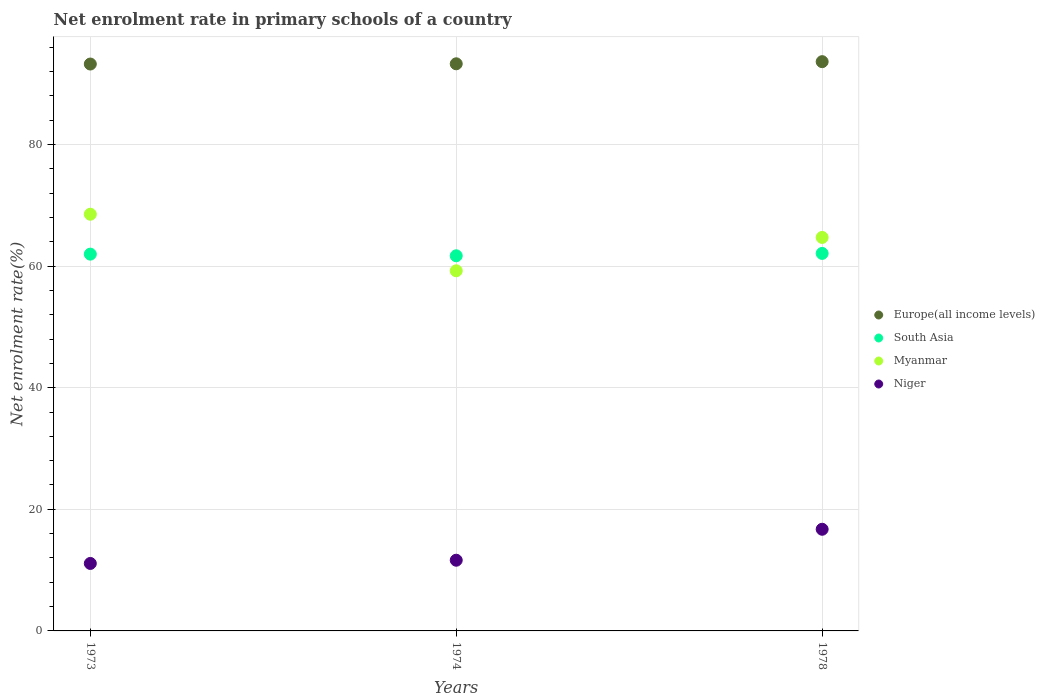How many different coloured dotlines are there?
Provide a succinct answer. 4. What is the net enrolment rate in primary schools in Myanmar in 1974?
Ensure brevity in your answer.  59.22. Across all years, what is the maximum net enrolment rate in primary schools in Europe(all income levels)?
Offer a terse response. 93.61. Across all years, what is the minimum net enrolment rate in primary schools in Myanmar?
Provide a short and direct response. 59.22. In which year was the net enrolment rate in primary schools in Europe(all income levels) maximum?
Provide a short and direct response. 1978. In which year was the net enrolment rate in primary schools in Europe(all income levels) minimum?
Provide a succinct answer. 1973. What is the total net enrolment rate in primary schools in South Asia in the graph?
Offer a very short reply. 185.73. What is the difference between the net enrolment rate in primary schools in Europe(all income levels) in 1973 and that in 1974?
Make the answer very short. -0.04. What is the difference between the net enrolment rate in primary schools in South Asia in 1973 and the net enrolment rate in primary schools in Niger in 1978?
Offer a terse response. 45.24. What is the average net enrolment rate in primary schools in South Asia per year?
Provide a succinct answer. 61.91. In the year 1973, what is the difference between the net enrolment rate in primary schools in Myanmar and net enrolment rate in primary schools in Niger?
Give a very brief answer. 57.43. In how many years, is the net enrolment rate in primary schools in Niger greater than 24 %?
Offer a very short reply. 0. What is the ratio of the net enrolment rate in primary schools in Europe(all income levels) in 1974 to that in 1978?
Make the answer very short. 1. Is the net enrolment rate in primary schools in Niger in 1973 less than that in 1974?
Provide a short and direct response. Yes. Is the difference between the net enrolment rate in primary schools in Myanmar in 1973 and 1974 greater than the difference between the net enrolment rate in primary schools in Niger in 1973 and 1974?
Provide a short and direct response. Yes. What is the difference between the highest and the second highest net enrolment rate in primary schools in Europe(all income levels)?
Your response must be concise. 0.35. What is the difference between the highest and the lowest net enrolment rate in primary schools in South Asia?
Offer a very short reply. 0.39. Is the sum of the net enrolment rate in primary schools in Myanmar in 1973 and 1974 greater than the maximum net enrolment rate in primary schools in Europe(all income levels) across all years?
Provide a succinct answer. Yes. Is it the case that in every year, the sum of the net enrolment rate in primary schools in South Asia and net enrolment rate in primary schools in Myanmar  is greater than the sum of net enrolment rate in primary schools in Niger and net enrolment rate in primary schools in Europe(all income levels)?
Offer a very short reply. Yes. Is it the case that in every year, the sum of the net enrolment rate in primary schools in Myanmar and net enrolment rate in primary schools in Europe(all income levels)  is greater than the net enrolment rate in primary schools in Niger?
Provide a short and direct response. Yes. Does the net enrolment rate in primary schools in Europe(all income levels) monotonically increase over the years?
Ensure brevity in your answer.  Yes. How many dotlines are there?
Give a very brief answer. 4. How many years are there in the graph?
Keep it short and to the point. 3. Does the graph contain any zero values?
Your answer should be very brief. No. Does the graph contain grids?
Keep it short and to the point. Yes. Where does the legend appear in the graph?
Make the answer very short. Center right. How many legend labels are there?
Ensure brevity in your answer.  4. How are the legend labels stacked?
Your answer should be compact. Vertical. What is the title of the graph?
Keep it short and to the point. Net enrolment rate in primary schools of a country. What is the label or title of the Y-axis?
Give a very brief answer. Net enrolment rate(%). What is the Net enrolment rate(%) of Europe(all income levels) in 1973?
Give a very brief answer. 93.22. What is the Net enrolment rate(%) in South Asia in 1973?
Ensure brevity in your answer.  61.96. What is the Net enrolment rate(%) in Myanmar in 1973?
Your answer should be compact. 68.52. What is the Net enrolment rate(%) in Niger in 1973?
Provide a short and direct response. 11.1. What is the Net enrolment rate(%) of Europe(all income levels) in 1974?
Make the answer very short. 93.26. What is the Net enrolment rate(%) in South Asia in 1974?
Give a very brief answer. 61.69. What is the Net enrolment rate(%) in Myanmar in 1974?
Ensure brevity in your answer.  59.22. What is the Net enrolment rate(%) in Niger in 1974?
Your response must be concise. 11.63. What is the Net enrolment rate(%) in Europe(all income levels) in 1978?
Keep it short and to the point. 93.61. What is the Net enrolment rate(%) of South Asia in 1978?
Your answer should be compact. 62.08. What is the Net enrolment rate(%) of Myanmar in 1978?
Provide a succinct answer. 64.71. What is the Net enrolment rate(%) of Niger in 1978?
Keep it short and to the point. 16.72. Across all years, what is the maximum Net enrolment rate(%) in Europe(all income levels)?
Offer a very short reply. 93.61. Across all years, what is the maximum Net enrolment rate(%) in South Asia?
Give a very brief answer. 62.08. Across all years, what is the maximum Net enrolment rate(%) in Myanmar?
Make the answer very short. 68.52. Across all years, what is the maximum Net enrolment rate(%) of Niger?
Give a very brief answer. 16.72. Across all years, what is the minimum Net enrolment rate(%) in Europe(all income levels)?
Offer a terse response. 93.22. Across all years, what is the minimum Net enrolment rate(%) of South Asia?
Offer a very short reply. 61.69. Across all years, what is the minimum Net enrolment rate(%) in Myanmar?
Make the answer very short. 59.22. Across all years, what is the minimum Net enrolment rate(%) in Niger?
Offer a very short reply. 11.1. What is the total Net enrolment rate(%) of Europe(all income levels) in the graph?
Ensure brevity in your answer.  280.1. What is the total Net enrolment rate(%) of South Asia in the graph?
Your answer should be very brief. 185.73. What is the total Net enrolment rate(%) in Myanmar in the graph?
Provide a short and direct response. 192.46. What is the total Net enrolment rate(%) of Niger in the graph?
Provide a succinct answer. 39.44. What is the difference between the Net enrolment rate(%) of Europe(all income levels) in 1973 and that in 1974?
Ensure brevity in your answer.  -0.04. What is the difference between the Net enrolment rate(%) of South Asia in 1973 and that in 1974?
Your answer should be very brief. 0.27. What is the difference between the Net enrolment rate(%) in Myanmar in 1973 and that in 1974?
Provide a succinct answer. 9.3. What is the difference between the Net enrolment rate(%) in Niger in 1973 and that in 1974?
Offer a very short reply. -0.53. What is the difference between the Net enrolment rate(%) of Europe(all income levels) in 1973 and that in 1978?
Your response must be concise. -0.39. What is the difference between the Net enrolment rate(%) in South Asia in 1973 and that in 1978?
Give a very brief answer. -0.12. What is the difference between the Net enrolment rate(%) of Myanmar in 1973 and that in 1978?
Give a very brief answer. 3.82. What is the difference between the Net enrolment rate(%) in Niger in 1973 and that in 1978?
Make the answer very short. -5.62. What is the difference between the Net enrolment rate(%) in Europe(all income levels) in 1974 and that in 1978?
Your answer should be compact. -0.35. What is the difference between the Net enrolment rate(%) of South Asia in 1974 and that in 1978?
Make the answer very short. -0.39. What is the difference between the Net enrolment rate(%) in Myanmar in 1974 and that in 1978?
Offer a very short reply. -5.49. What is the difference between the Net enrolment rate(%) in Niger in 1974 and that in 1978?
Make the answer very short. -5.09. What is the difference between the Net enrolment rate(%) in Europe(all income levels) in 1973 and the Net enrolment rate(%) in South Asia in 1974?
Offer a terse response. 31.53. What is the difference between the Net enrolment rate(%) in Europe(all income levels) in 1973 and the Net enrolment rate(%) in Myanmar in 1974?
Your response must be concise. 34. What is the difference between the Net enrolment rate(%) of Europe(all income levels) in 1973 and the Net enrolment rate(%) of Niger in 1974?
Provide a succinct answer. 81.6. What is the difference between the Net enrolment rate(%) in South Asia in 1973 and the Net enrolment rate(%) in Myanmar in 1974?
Provide a succinct answer. 2.74. What is the difference between the Net enrolment rate(%) in South Asia in 1973 and the Net enrolment rate(%) in Niger in 1974?
Offer a very short reply. 50.33. What is the difference between the Net enrolment rate(%) in Myanmar in 1973 and the Net enrolment rate(%) in Niger in 1974?
Ensure brevity in your answer.  56.9. What is the difference between the Net enrolment rate(%) of Europe(all income levels) in 1973 and the Net enrolment rate(%) of South Asia in 1978?
Your answer should be very brief. 31.14. What is the difference between the Net enrolment rate(%) in Europe(all income levels) in 1973 and the Net enrolment rate(%) in Myanmar in 1978?
Your answer should be very brief. 28.51. What is the difference between the Net enrolment rate(%) of Europe(all income levels) in 1973 and the Net enrolment rate(%) of Niger in 1978?
Your response must be concise. 76.51. What is the difference between the Net enrolment rate(%) of South Asia in 1973 and the Net enrolment rate(%) of Myanmar in 1978?
Offer a very short reply. -2.75. What is the difference between the Net enrolment rate(%) in South Asia in 1973 and the Net enrolment rate(%) in Niger in 1978?
Give a very brief answer. 45.24. What is the difference between the Net enrolment rate(%) in Myanmar in 1973 and the Net enrolment rate(%) in Niger in 1978?
Your answer should be very brief. 51.81. What is the difference between the Net enrolment rate(%) of Europe(all income levels) in 1974 and the Net enrolment rate(%) of South Asia in 1978?
Offer a very short reply. 31.18. What is the difference between the Net enrolment rate(%) in Europe(all income levels) in 1974 and the Net enrolment rate(%) in Myanmar in 1978?
Offer a terse response. 28.55. What is the difference between the Net enrolment rate(%) of Europe(all income levels) in 1974 and the Net enrolment rate(%) of Niger in 1978?
Offer a very short reply. 76.55. What is the difference between the Net enrolment rate(%) in South Asia in 1974 and the Net enrolment rate(%) in Myanmar in 1978?
Offer a very short reply. -3.02. What is the difference between the Net enrolment rate(%) of South Asia in 1974 and the Net enrolment rate(%) of Niger in 1978?
Keep it short and to the point. 44.97. What is the difference between the Net enrolment rate(%) of Myanmar in 1974 and the Net enrolment rate(%) of Niger in 1978?
Keep it short and to the point. 42.51. What is the average Net enrolment rate(%) of Europe(all income levels) per year?
Ensure brevity in your answer.  93.37. What is the average Net enrolment rate(%) of South Asia per year?
Make the answer very short. 61.91. What is the average Net enrolment rate(%) of Myanmar per year?
Provide a succinct answer. 64.15. What is the average Net enrolment rate(%) in Niger per year?
Provide a short and direct response. 13.15. In the year 1973, what is the difference between the Net enrolment rate(%) in Europe(all income levels) and Net enrolment rate(%) in South Asia?
Ensure brevity in your answer.  31.26. In the year 1973, what is the difference between the Net enrolment rate(%) of Europe(all income levels) and Net enrolment rate(%) of Myanmar?
Keep it short and to the point. 24.7. In the year 1973, what is the difference between the Net enrolment rate(%) of Europe(all income levels) and Net enrolment rate(%) of Niger?
Offer a terse response. 82.13. In the year 1973, what is the difference between the Net enrolment rate(%) in South Asia and Net enrolment rate(%) in Myanmar?
Your answer should be very brief. -6.56. In the year 1973, what is the difference between the Net enrolment rate(%) in South Asia and Net enrolment rate(%) in Niger?
Give a very brief answer. 50.86. In the year 1973, what is the difference between the Net enrolment rate(%) of Myanmar and Net enrolment rate(%) of Niger?
Offer a terse response. 57.43. In the year 1974, what is the difference between the Net enrolment rate(%) of Europe(all income levels) and Net enrolment rate(%) of South Asia?
Your answer should be very brief. 31.57. In the year 1974, what is the difference between the Net enrolment rate(%) of Europe(all income levels) and Net enrolment rate(%) of Myanmar?
Your response must be concise. 34.04. In the year 1974, what is the difference between the Net enrolment rate(%) of Europe(all income levels) and Net enrolment rate(%) of Niger?
Offer a terse response. 81.64. In the year 1974, what is the difference between the Net enrolment rate(%) of South Asia and Net enrolment rate(%) of Myanmar?
Keep it short and to the point. 2.47. In the year 1974, what is the difference between the Net enrolment rate(%) in South Asia and Net enrolment rate(%) in Niger?
Your response must be concise. 50.06. In the year 1974, what is the difference between the Net enrolment rate(%) of Myanmar and Net enrolment rate(%) of Niger?
Your answer should be compact. 47.6. In the year 1978, what is the difference between the Net enrolment rate(%) in Europe(all income levels) and Net enrolment rate(%) in South Asia?
Offer a terse response. 31.53. In the year 1978, what is the difference between the Net enrolment rate(%) of Europe(all income levels) and Net enrolment rate(%) of Myanmar?
Provide a succinct answer. 28.9. In the year 1978, what is the difference between the Net enrolment rate(%) in Europe(all income levels) and Net enrolment rate(%) in Niger?
Give a very brief answer. 76.9. In the year 1978, what is the difference between the Net enrolment rate(%) in South Asia and Net enrolment rate(%) in Myanmar?
Provide a succinct answer. -2.63. In the year 1978, what is the difference between the Net enrolment rate(%) in South Asia and Net enrolment rate(%) in Niger?
Your response must be concise. 45.36. In the year 1978, what is the difference between the Net enrolment rate(%) of Myanmar and Net enrolment rate(%) of Niger?
Provide a succinct answer. 47.99. What is the ratio of the Net enrolment rate(%) in South Asia in 1973 to that in 1974?
Your answer should be very brief. 1. What is the ratio of the Net enrolment rate(%) in Myanmar in 1973 to that in 1974?
Your response must be concise. 1.16. What is the ratio of the Net enrolment rate(%) in Niger in 1973 to that in 1974?
Your answer should be compact. 0.95. What is the ratio of the Net enrolment rate(%) in South Asia in 1973 to that in 1978?
Your answer should be compact. 1. What is the ratio of the Net enrolment rate(%) in Myanmar in 1973 to that in 1978?
Provide a succinct answer. 1.06. What is the ratio of the Net enrolment rate(%) in Niger in 1973 to that in 1978?
Your response must be concise. 0.66. What is the ratio of the Net enrolment rate(%) in Europe(all income levels) in 1974 to that in 1978?
Your answer should be compact. 1. What is the ratio of the Net enrolment rate(%) in Myanmar in 1974 to that in 1978?
Your answer should be very brief. 0.92. What is the ratio of the Net enrolment rate(%) in Niger in 1974 to that in 1978?
Keep it short and to the point. 0.7. What is the difference between the highest and the second highest Net enrolment rate(%) of Europe(all income levels)?
Your answer should be compact. 0.35. What is the difference between the highest and the second highest Net enrolment rate(%) of South Asia?
Your answer should be very brief. 0.12. What is the difference between the highest and the second highest Net enrolment rate(%) of Myanmar?
Provide a succinct answer. 3.82. What is the difference between the highest and the second highest Net enrolment rate(%) in Niger?
Offer a terse response. 5.09. What is the difference between the highest and the lowest Net enrolment rate(%) in Europe(all income levels)?
Provide a succinct answer. 0.39. What is the difference between the highest and the lowest Net enrolment rate(%) of South Asia?
Make the answer very short. 0.39. What is the difference between the highest and the lowest Net enrolment rate(%) of Myanmar?
Offer a terse response. 9.3. What is the difference between the highest and the lowest Net enrolment rate(%) of Niger?
Offer a terse response. 5.62. 